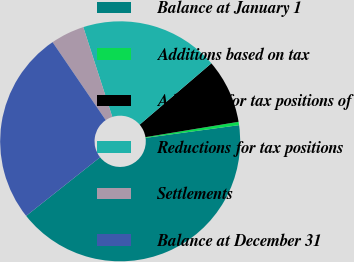Convert chart. <chart><loc_0><loc_0><loc_500><loc_500><pie_chart><fcel>Balance at January 1<fcel>Additions based on tax<fcel>Additions for tax positions of<fcel>Reductions for tax positions<fcel>Settlements<fcel>Balance at December 31<nl><fcel>41.48%<fcel>0.45%<fcel>8.66%<fcel>18.71%<fcel>4.55%<fcel>26.15%<nl></chart> 